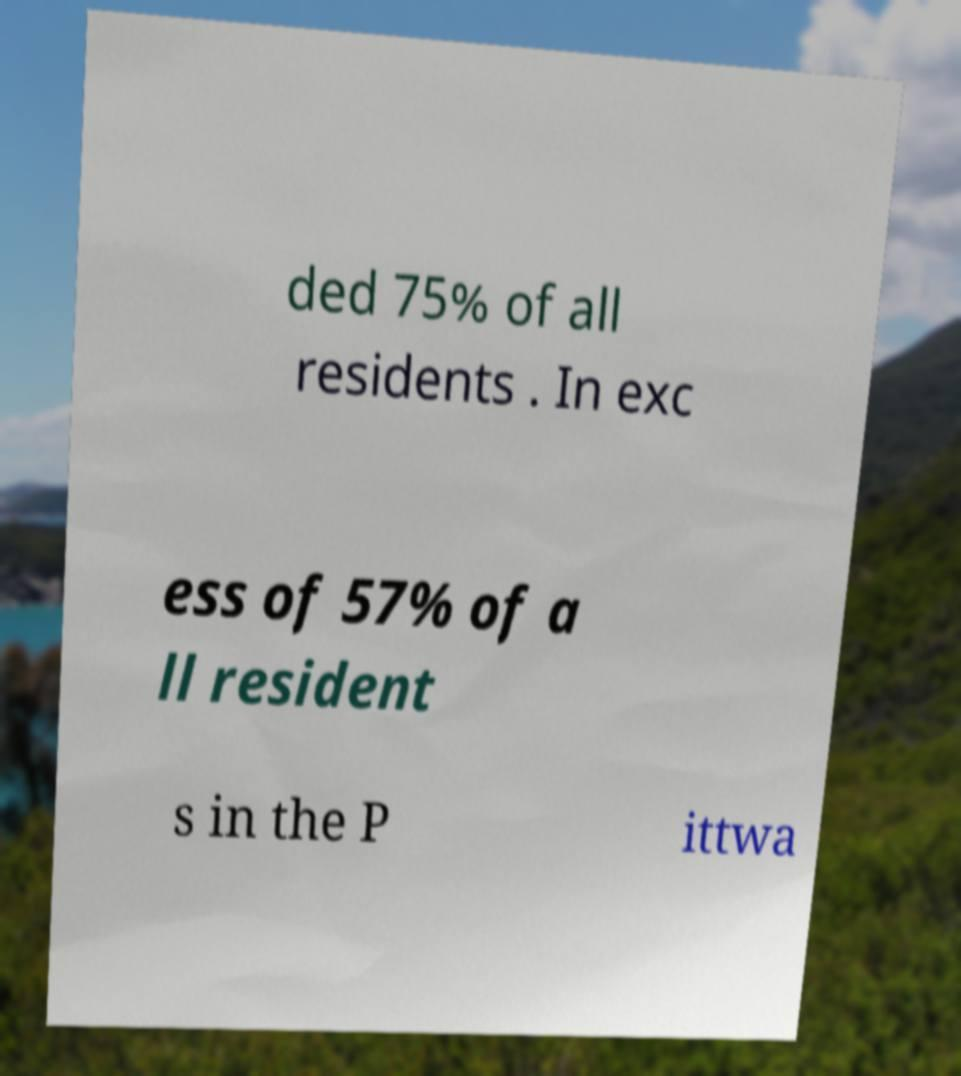Please identify and transcribe the text found in this image. ded 75% of all residents . In exc ess of 57% of a ll resident s in the P ittwa 